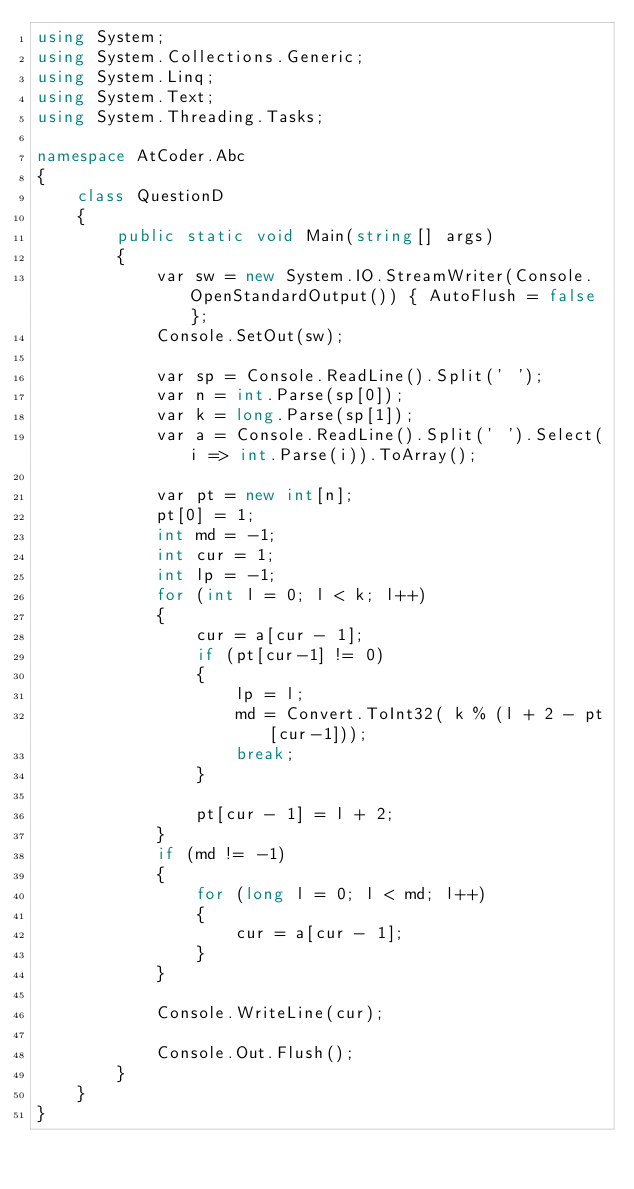<code> <loc_0><loc_0><loc_500><loc_500><_C#_>using System;
using System.Collections.Generic;
using System.Linq;
using System.Text;
using System.Threading.Tasks;

namespace AtCoder.Abc
{
    class QuestionD
    {
        public static void Main(string[] args)
        {
            var sw = new System.IO.StreamWriter(Console.OpenStandardOutput()) { AutoFlush = false };
            Console.SetOut(sw);

            var sp = Console.ReadLine().Split(' ');
            var n = int.Parse(sp[0]);
            var k = long.Parse(sp[1]);
            var a = Console.ReadLine().Split(' ').Select(i => int.Parse(i)).ToArray();

            var pt = new int[n];
            pt[0] = 1;
            int md = -1;
            int cur = 1;
            int lp = -1;
            for (int l = 0; l < k; l++)
            {
                cur = a[cur - 1];
                if (pt[cur-1] != 0)
                {
                    lp = l;
                    md = Convert.ToInt32( k % (l + 2 - pt[cur-1]));
                    break;
                }

                pt[cur - 1] = l + 2;
            }
            if (md != -1)
            {
                for (long l = 0; l < md; l++)
                {
                    cur = a[cur - 1];
                }
            }

            Console.WriteLine(cur);

            Console.Out.Flush();
        }
    }
}
</code> 